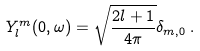<formula> <loc_0><loc_0><loc_500><loc_500>Y ^ { m } _ { l } ( 0 , \omega ) = \sqrt { \frac { 2 l + 1 } { 4 \pi } } \delta _ { m , 0 } \, .</formula> 